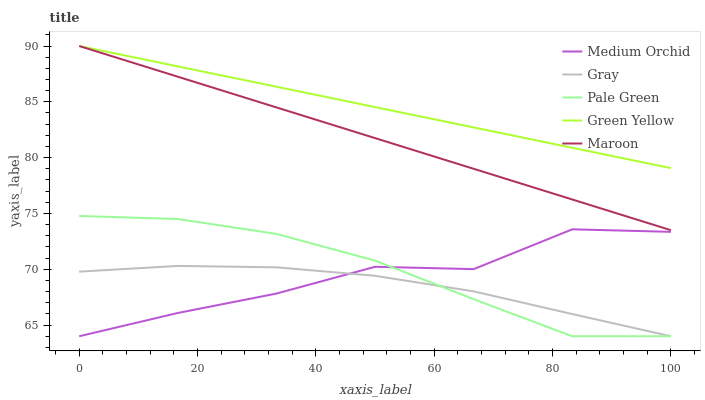Does Gray have the minimum area under the curve?
Answer yes or no. Yes. Does Green Yellow have the maximum area under the curve?
Answer yes or no. Yes. Does Pale Green have the minimum area under the curve?
Answer yes or no. No. Does Pale Green have the maximum area under the curve?
Answer yes or no. No. Is Maroon the smoothest?
Answer yes or no. Yes. Is Medium Orchid the roughest?
Answer yes or no. Yes. Is Pale Green the smoothest?
Answer yes or no. No. Is Pale Green the roughest?
Answer yes or no. No. Does Gray have the lowest value?
Answer yes or no. Yes. Does Green Yellow have the lowest value?
Answer yes or no. No. Does Maroon have the highest value?
Answer yes or no. Yes. Does Pale Green have the highest value?
Answer yes or no. No. Is Medium Orchid less than Green Yellow?
Answer yes or no. Yes. Is Green Yellow greater than Medium Orchid?
Answer yes or no. Yes. Does Medium Orchid intersect Gray?
Answer yes or no. Yes. Is Medium Orchid less than Gray?
Answer yes or no. No. Is Medium Orchid greater than Gray?
Answer yes or no. No. Does Medium Orchid intersect Green Yellow?
Answer yes or no. No. 